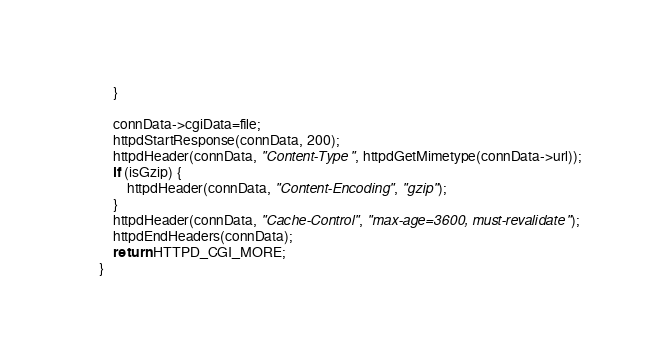Convert code to text. <code><loc_0><loc_0><loc_500><loc_500><_C_>		}

		connData->cgiData=file;
		httpdStartResponse(connData, 200);
		httpdHeader(connData, "Content-Type", httpdGetMimetype(connData->url));
		if (isGzip) {
			httpdHeader(connData, "Content-Encoding", "gzip");
		}
		httpdHeader(connData, "Cache-Control", "max-age=3600, must-revalidate");
		httpdEndHeaders(connData);
		return HTTPD_CGI_MORE;
	}
</code> 